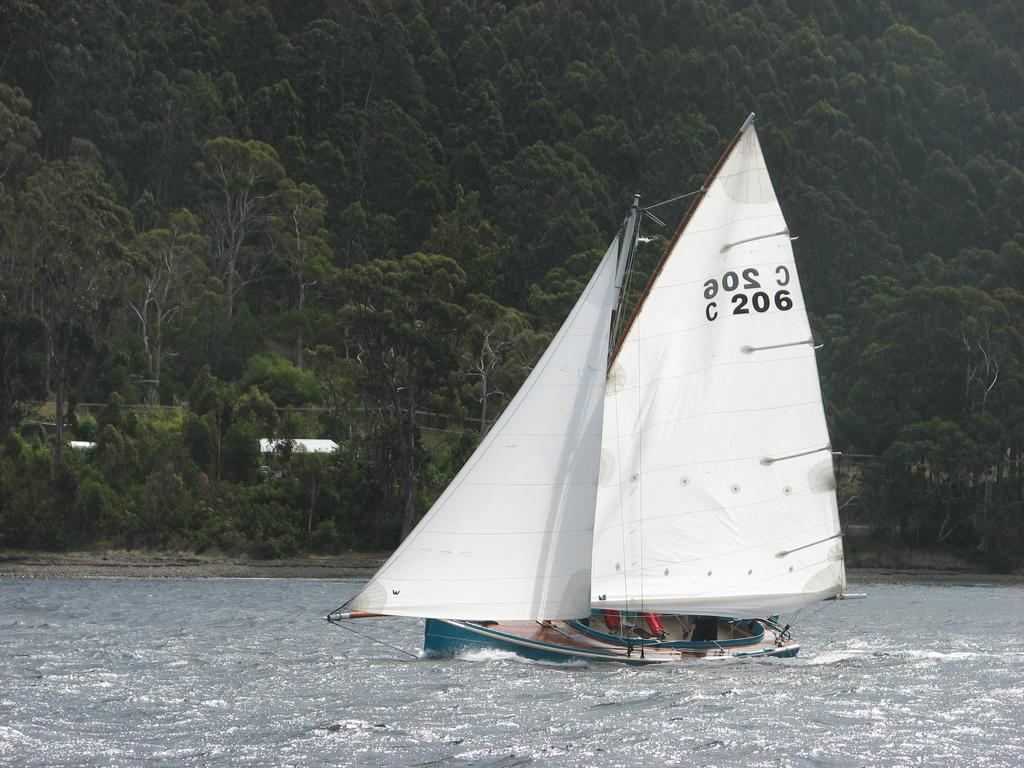What is the main subject of the image? The main subject of the image is a boat. Where is the boat located? The boat is on the water. What can be seen above the boat in the image? There are two white color objects above the boat. What is visible in the background of the image? There are trees in the background of the image. How many pieces of waste can be seen floating in the water near the boat? There is no waste visible in the image; it only shows a boat on the water with two white color objects above it and trees in the background. 